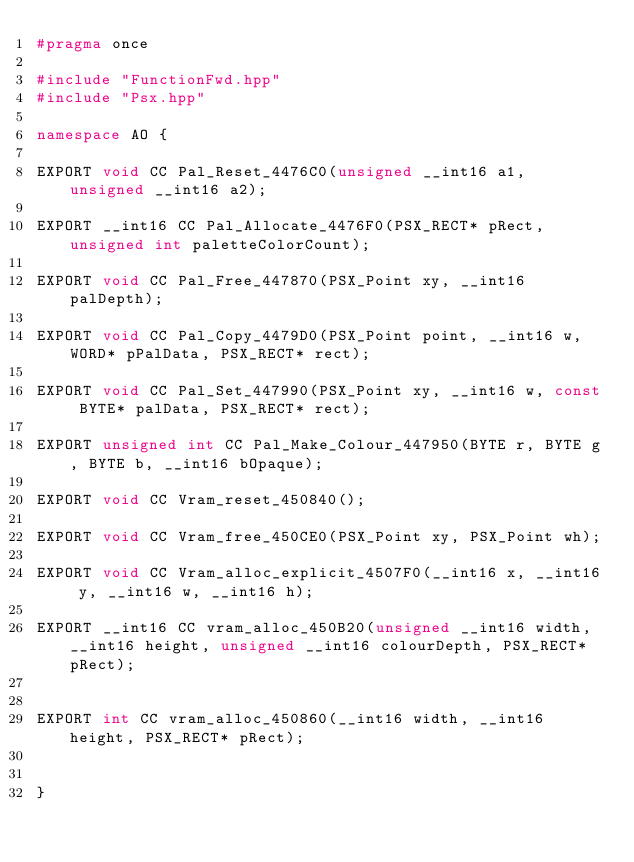<code> <loc_0><loc_0><loc_500><loc_500><_C++_>#pragma once

#include "FunctionFwd.hpp"
#include "Psx.hpp"

namespace AO {

EXPORT void CC Pal_Reset_4476C0(unsigned __int16 a1, unsigned __int16 a2);

EXPORT __int16 CC Pal_Allocate_4476F0(PSX_RECT* pRect, unsigned int paletteColorCount);

EXPORT void CC Pal_Free_447870(PSX_Point xy, __int16 palDepth);

EXPORT void CC Pal_Copy_4479D0(PSX_Point point, __int16 w, WORD* pPalData, PSX_RECT* rect);

EXPORT void CC Pal_Set_447990(PSX_Point xy, __int16 w, const BYTE* palData, PSX_RECT* rect);

EXPORT unsigned int CC Pal_Make_Colour_447950(BYTE r, BYTE g, BYTE b, __int16 bOpaque);

EXPORT void CC Vram_reset_450840();

EXPORT void CC Vram_free_450CE0(PSX_Point xy, PSX_Point wh);

EXPORT void CC Vram_alloc_explicit_4507F0(__int16 x, __int16 y, __int16 w, __int16 h);

EXPORT __int16 CC vram_alloc_450B20(unsigned __int16 width, __int16 height, unsigned __int16 colourDepth, PSX_RECT* pRect);


EXPORT int CC vram_alloc_450860(__int16 width, __int16 height, PSX_RECT* pRect);


}
</code> 